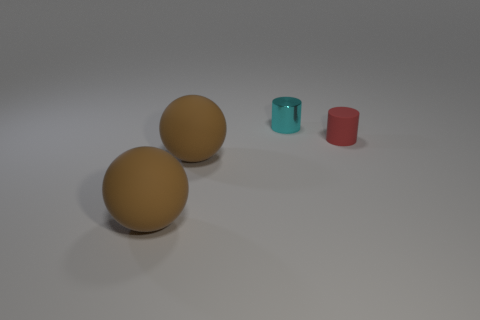Add 3 tiny cyan metal cylinders. How many objects exist? 7 Subtract all blue matte spheres. Subtract all large brown matte spheres. How many objects are left? 2 Add 2 matte cylinders. How many matte cylinders are left? 3 Add 1 red rubber objects. How many red rubber objects exist? 2 Subtract 0 gray cubes. How many objects are left? 4 